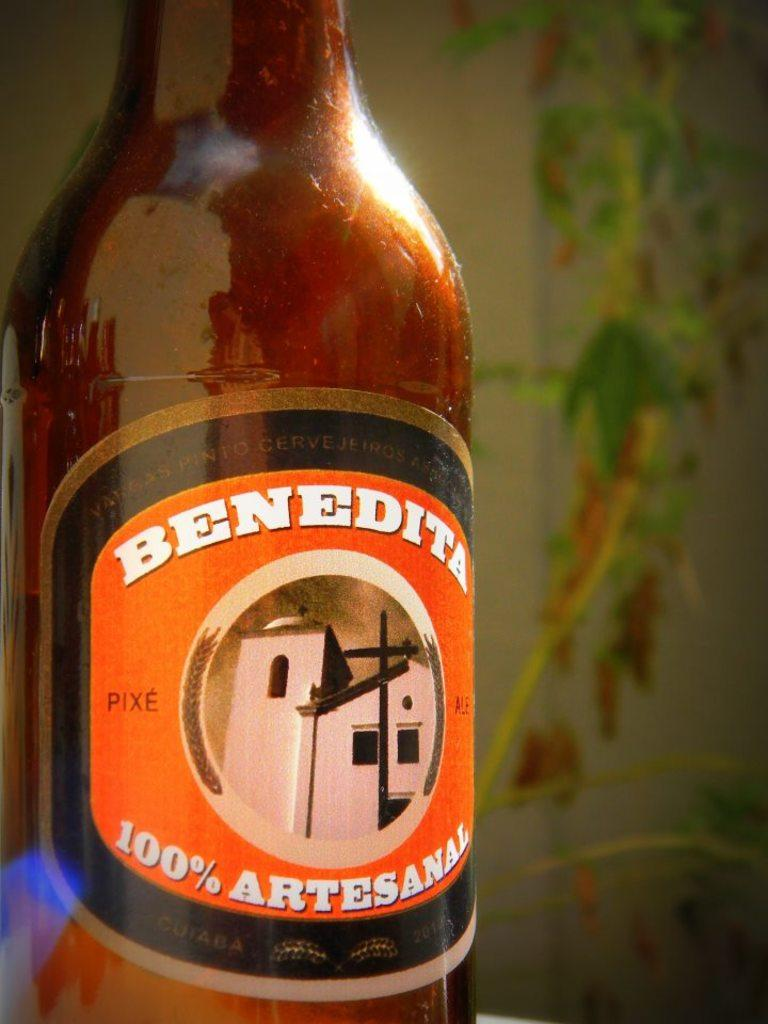Provide a one-sentence caption for the provided image. Close up of a bottle of Benedita 100 percent artesanal beverage. 